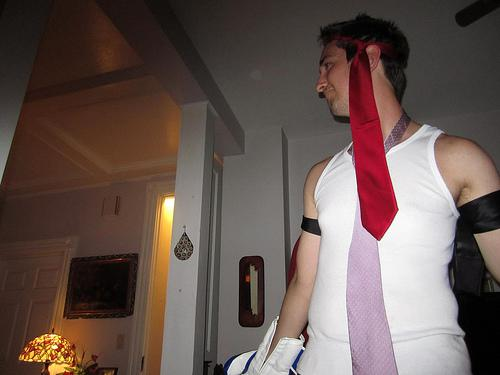Question: where is he looking?
Choices:
A. At his watch.
B. Out a window.
C. To the other room on his right.
D. At his computer screen.
Answer with the letter. Answer: C Question: what kind of small lamp is in the other room?
Choices:
A. One with a purple lampshade.
B. A blue one on a small table.
C. One that has flowers on it.
D. One with a stained glass shade.
Answer with the letter. Answer: D Question: where is the man standing?
Choices:
A. At a bus stop.
B. Inside of a public bathroom.
C. In a room of a home or apartment.
D. Outside at some sort of park.
Answer with the letter. Answer: C Question: what shape is the door frame to the man's right?
Choices:
A. Circular.
B. Rectangular.
C. Triangular.
D. Square.
Answer with the letter. Answer: B 